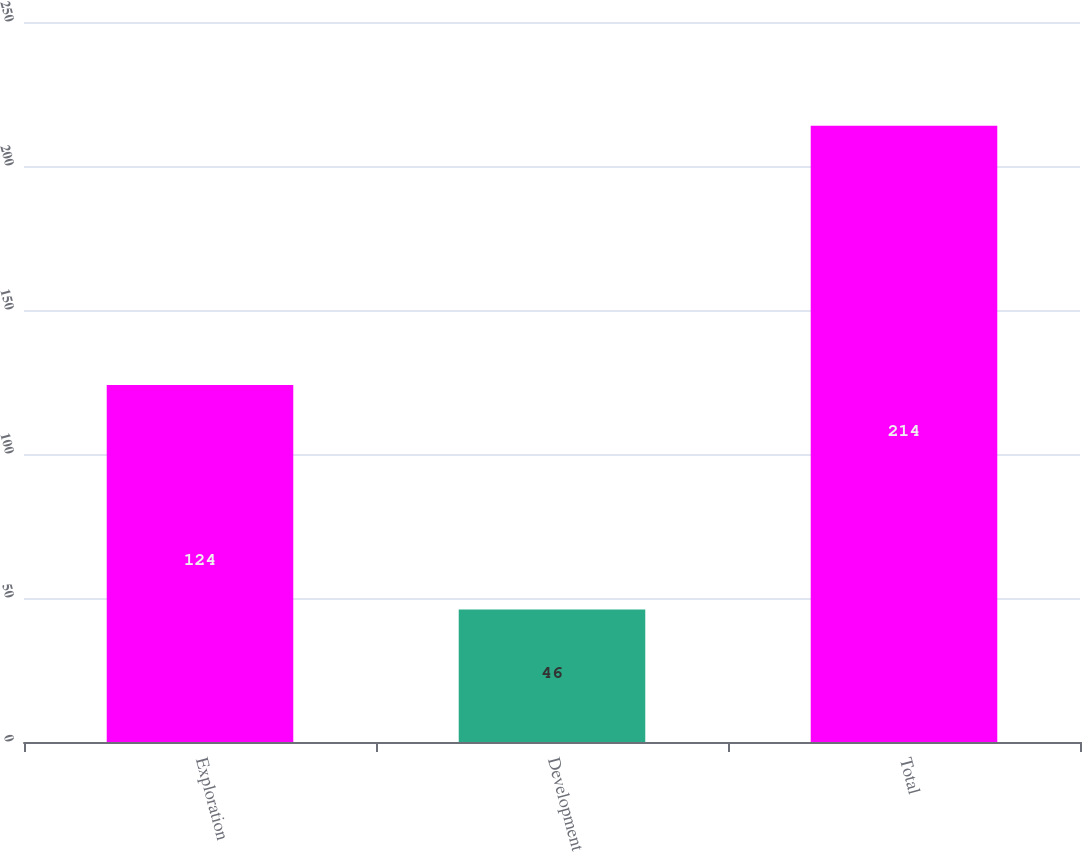Convert chart. <chart><loc_0><loc_0><loc_500><loc_500><bar_chart><fcel>Exploration<fcel>Development<fcel>Total<nl><fcel>124<fcel>46<fcel>214<nl></chart> 